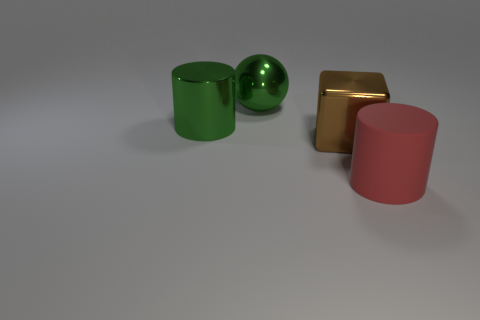Subtract all red cylinders. Subtract all cyan spheres. How many cylinders are left? 1 Add 2 big purple rubber spheres. How many objects exist? 6 Subtract all cubes. How many objects are left? 3 Subtract all small gray rubber cubes. Subtract all large red rubber things. How many objects are left? 3 Add 3 red objects. How many red objects are left? 4 Add 2 small red spheres. How many small red spheres exist? 2 Subtract 0 brown cylinders. How many objects are left? 4 